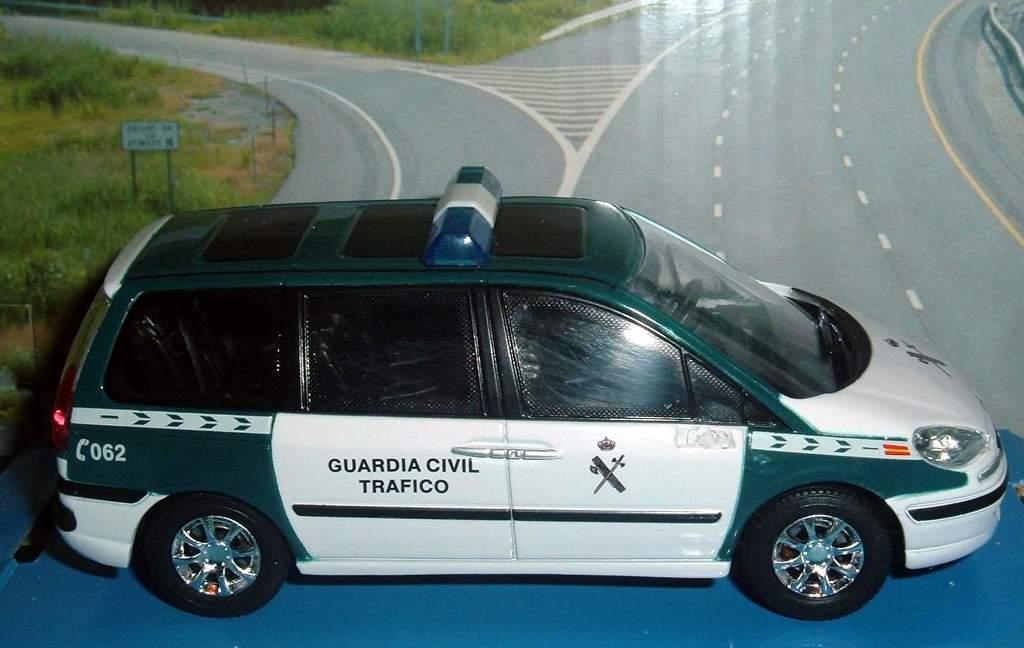Are they going to guard us in the streets?
Your answer should be very brief. Yes. What is the emergency number on the car?
Your answer should be compact. 062. 